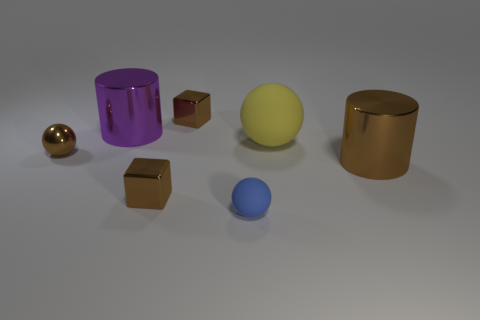What shape is the large shiny thing in front of the purple cylinder? The large shiny object in front of the purple cylinder has a cylindrical shape with a reflective gold finish. 